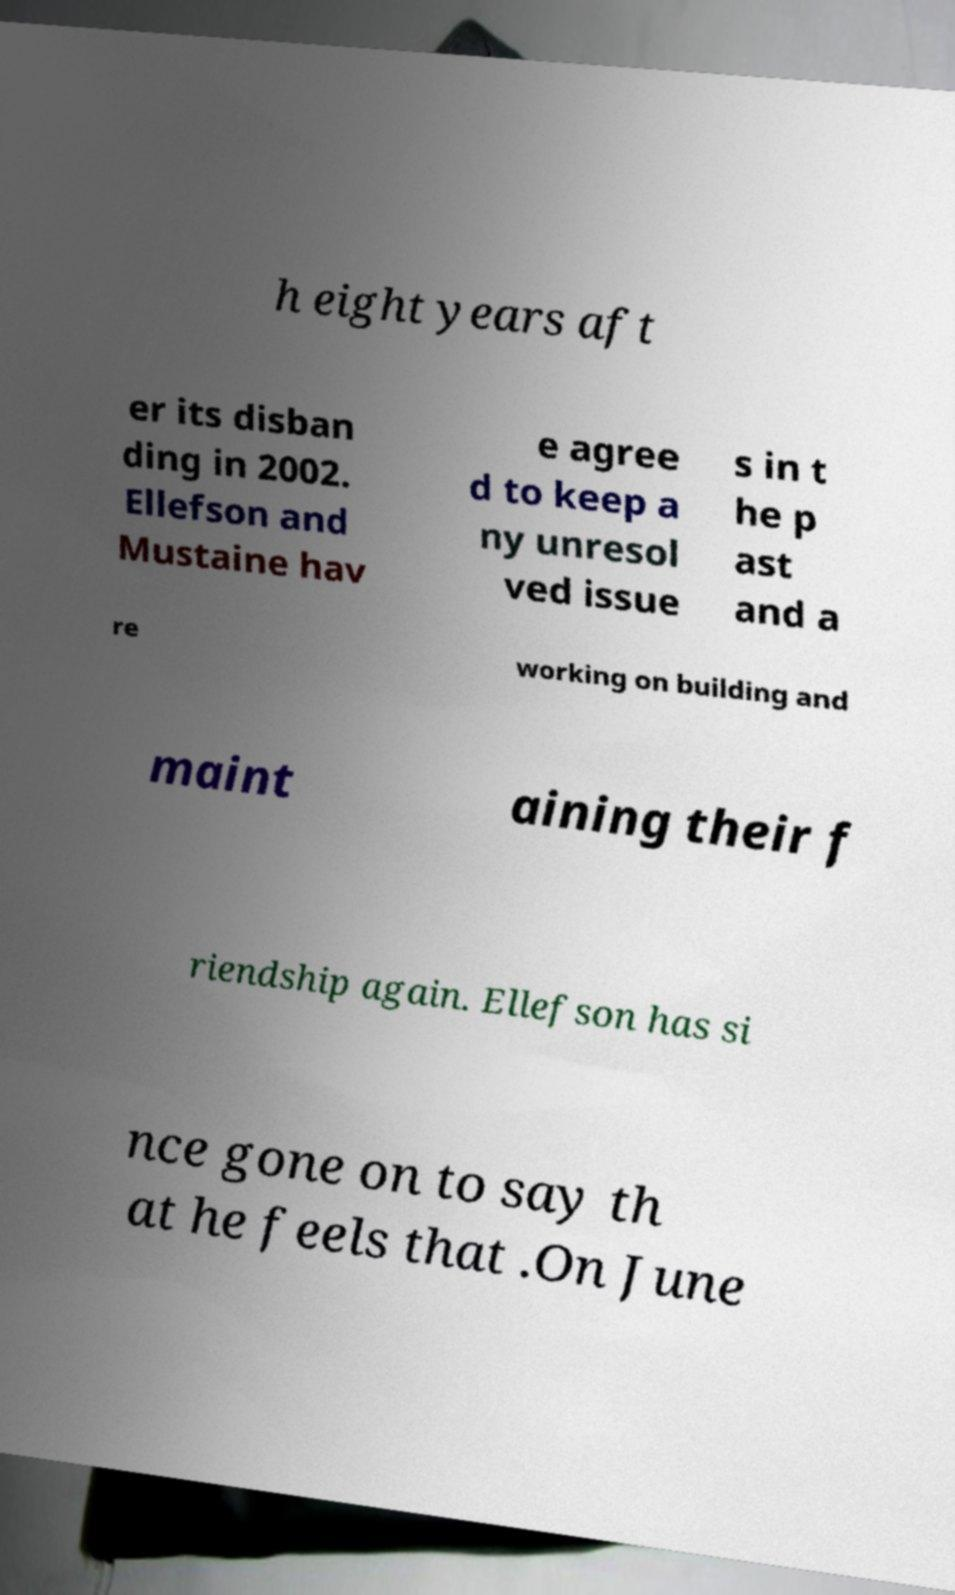Can you accurately transcribe the text from the provided image for me? h eight years aft er its disban ding in 2002. Ellefson and Mustaine hav e agree d to keep a ny unresol ved issue s in t he p ast and a re working on building and maint aining their f riendship again. Ellefson has si nce gone on to say th at he feels that .On June 